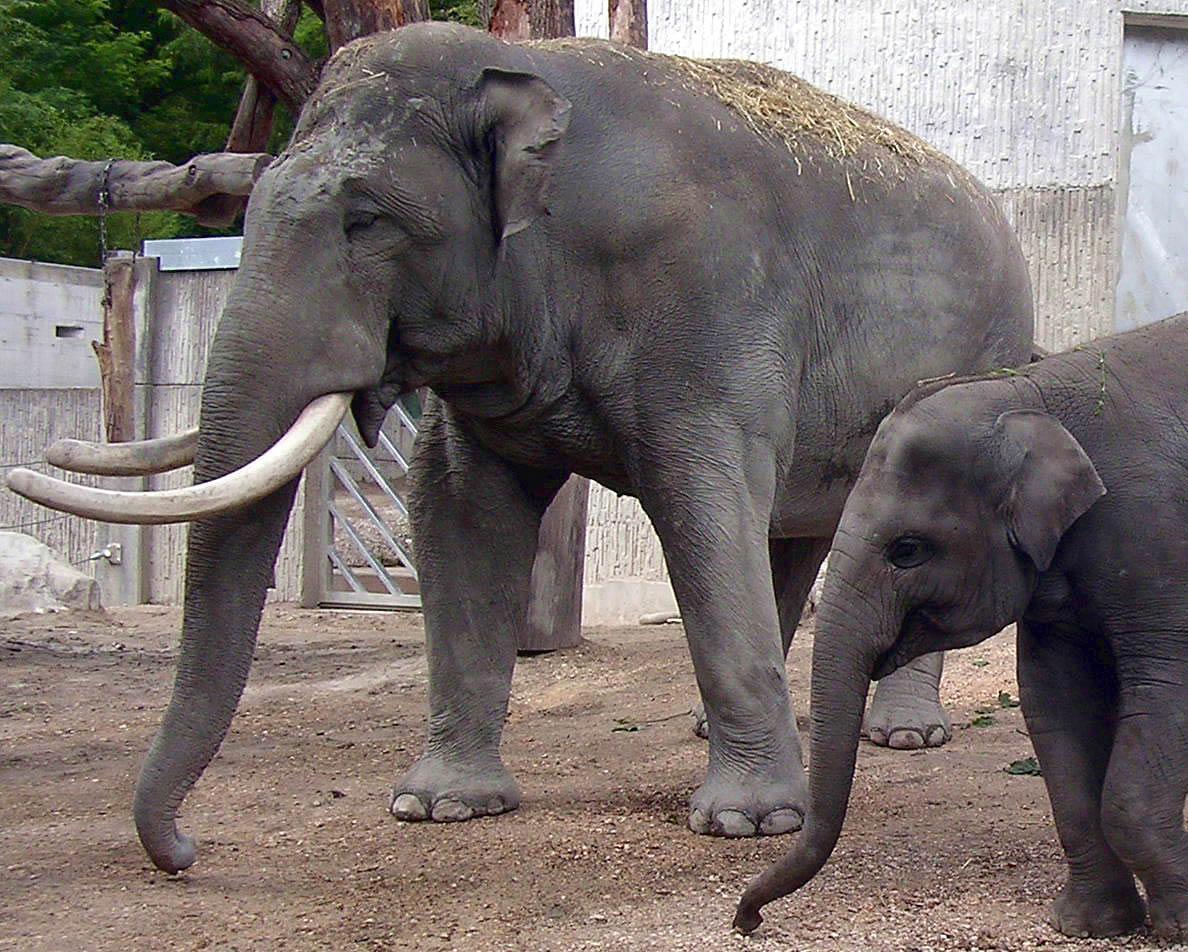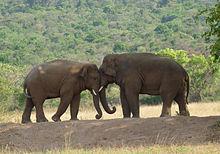The first image is the image on the left, the second image is the image on the right. Evaluate the accuracy of this statement regarding the images: "There are two adult elephants in the image on the right.". Is it true? Answer yes or no. Yes. The first image is the image on the left, the second image is the image on the right. Evaluate the accuracy of this statement regarding the images: "Three elephants walk together in the image on the left.". Is it true? Answer yes or no. No. The first image is the image on the left, the second image is the image on the right. For the images displayed, is the sentence "One image includes leftward-facing adult and young elephants." factually correct? Answer yes or no. Yes. 